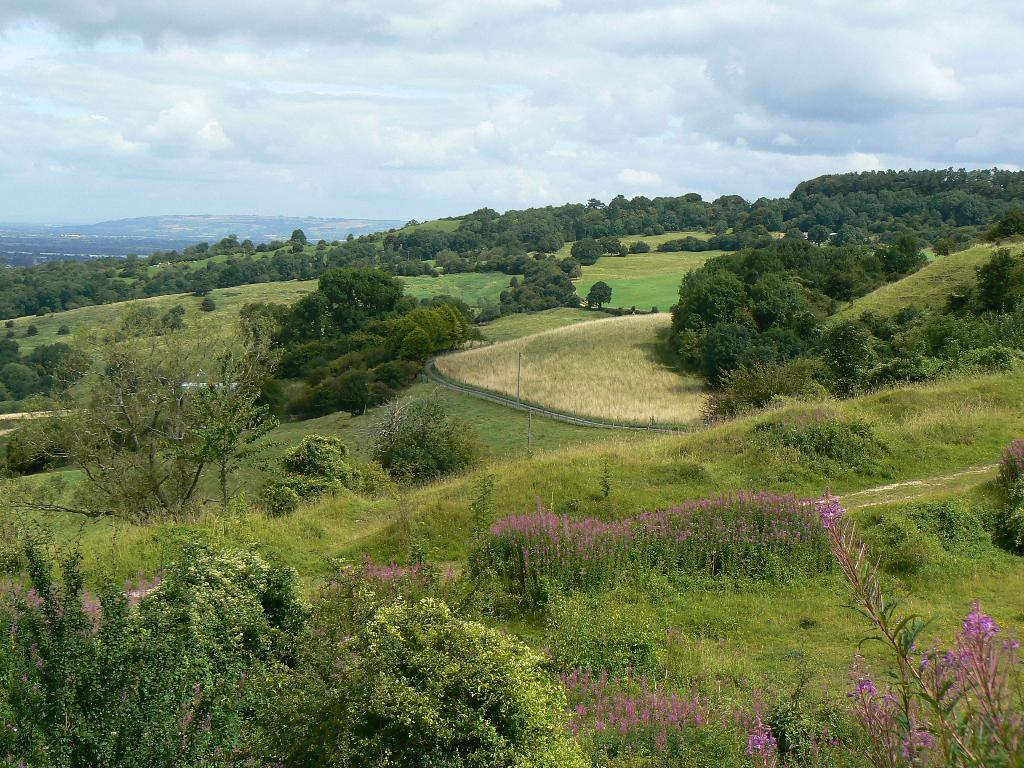What type of vegetation can be seen in the image? There are trees, plants, flowers, and grass visible in the image. What natural features are present in the image? There are hills in the image. What part of the natural environment is visible in the image? The sky is visible in the image, and there are clouds present. What time of day is it in the image, based on the comfort level of the dirt? There is no dirt present in the image, and the comfort level of dirt cannot be determined from the image. 